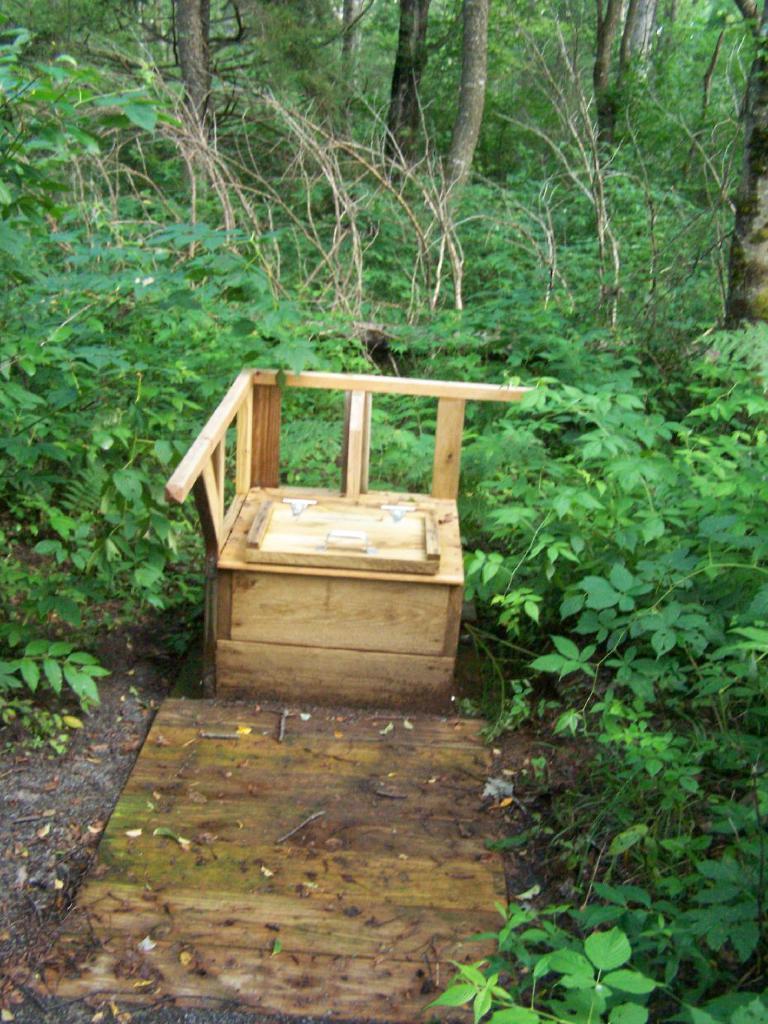In one or two sentences, can you explain what this image depicts? In the picture I can see the wooden objects, plants, dry leaves on the ground and trees in the background. 